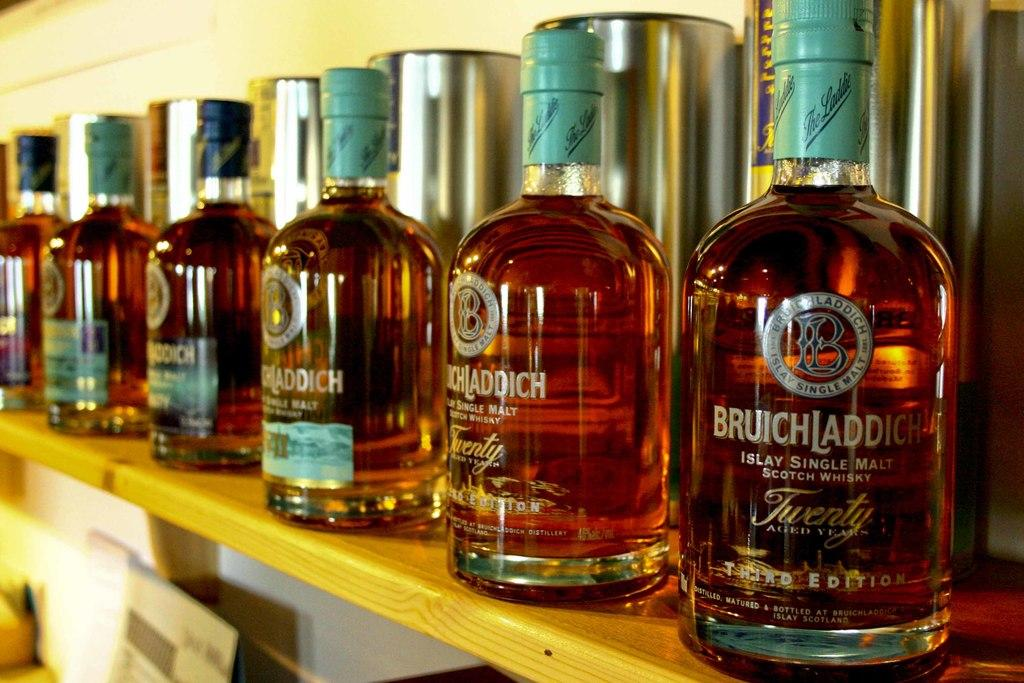Provide a one-sentence caption for the provided image. A shelf with bottles Bruichladdick Scotch Whiskey lined up. 